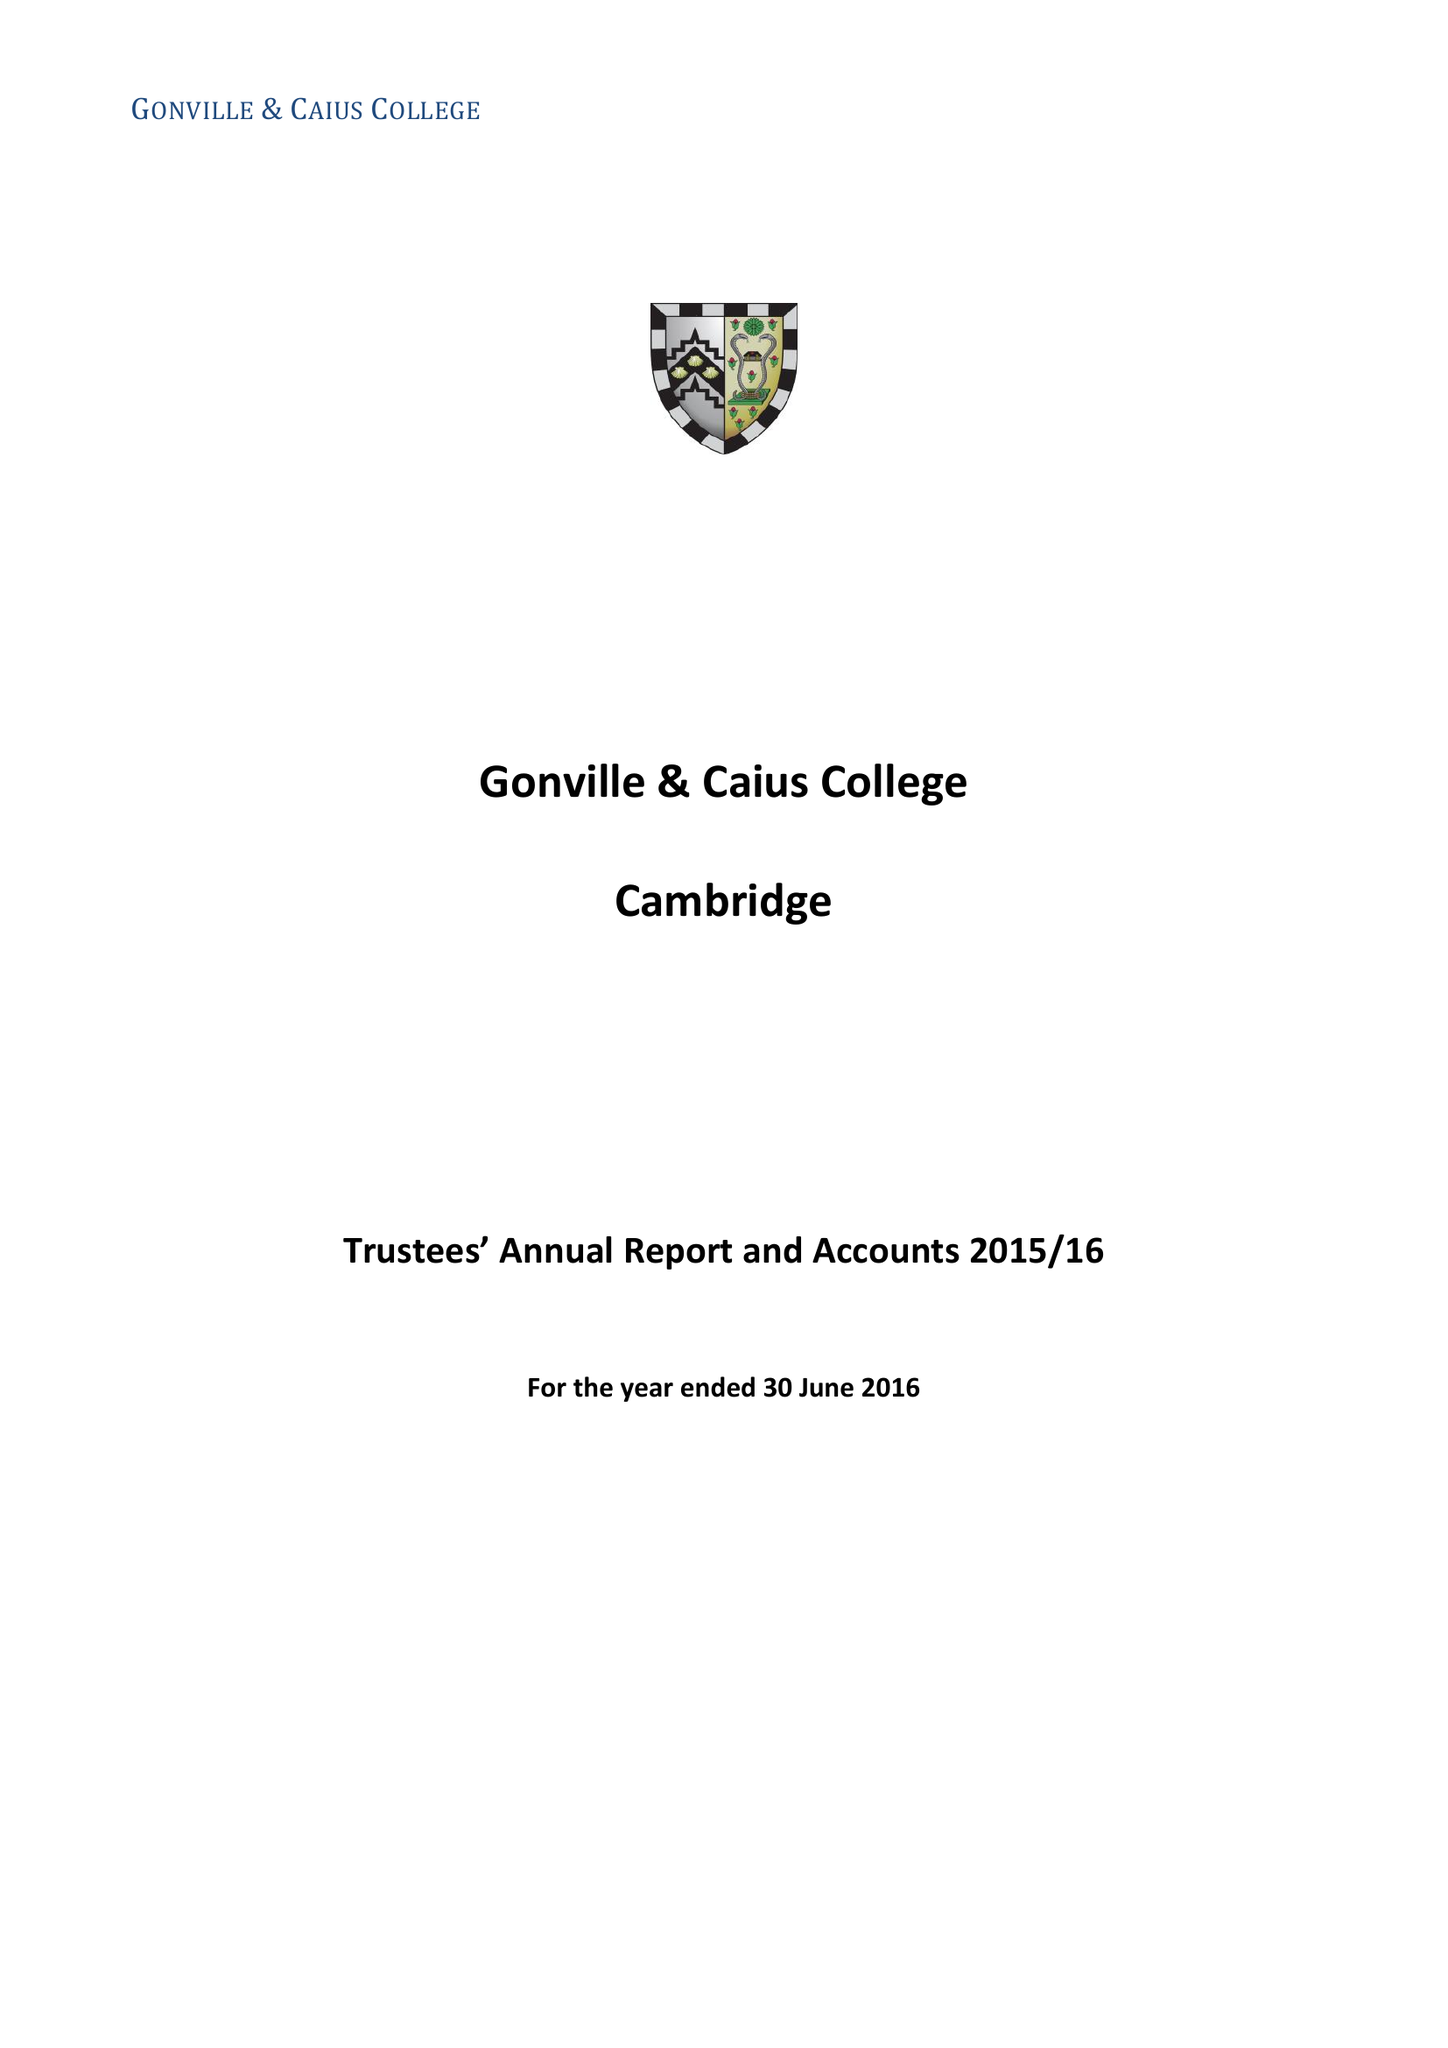What is the value for the address__post_town?
Answer the question using a single word or phrase. CAMBRIDGE 